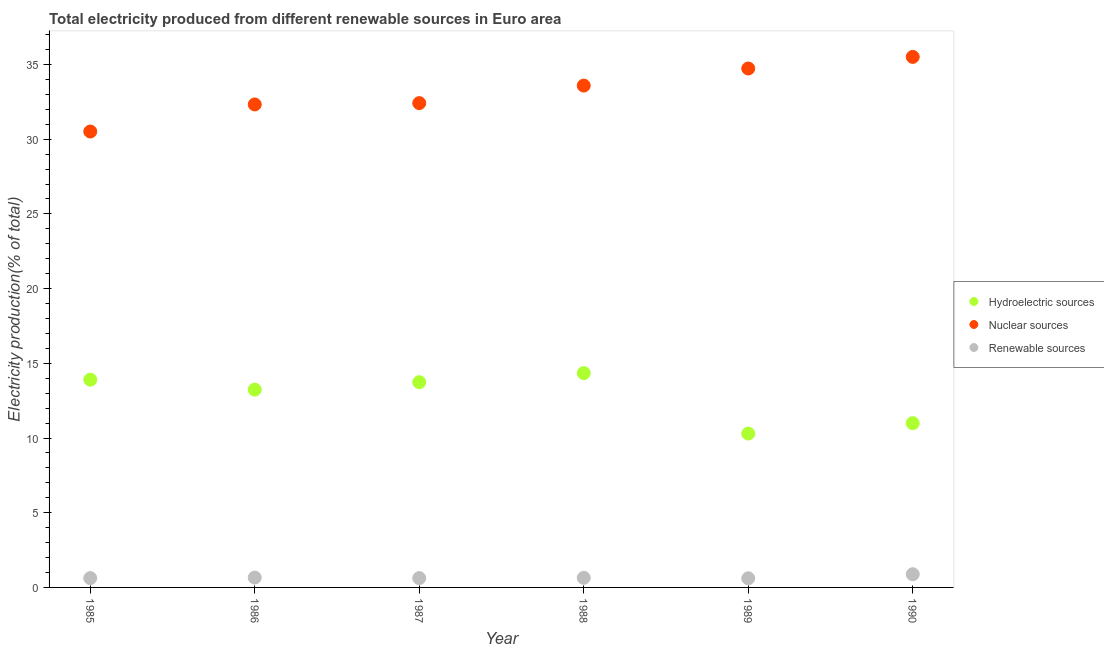What is the percentage of electricity produced by hydroelectric sources in 1988?
Make the answer very short. 14.34. Across all years, what is the maximum percentage of electricity produced by renewable sources?
Ensure brevity in your answer.  0.88. Across all years, what is the minimum percentage of electricity produced by nuclear sources?
Your response must be concise. 30.52. In which year was the percentage of electricity produced by renewable sources maximum?
Ensure brevity in your answer.  1990. What is the total percentage of electricity produced by nuclear sources in the graph?
Give a very brief answer. 199.1. What is the difference between the percentage of electricity produced by renewable sources in 1985 and that in 1990?
Offer a terse response. -0.26. What is the difference between the percentage of electricity produced by nuclear sources in 1987 and the percentage of electricity produced by renewable sources in 1988?
Provide a succinct answer. 31.77. What is the average percentage of electricity produced by renewable sources per year?
Provide a succinct answer. 0.67. In the year 1987, what is the difference between the percentage of electricity produced by nuclear sources and percentage of electricity produced by renewable sources?
Keep it short and to the point. 31.79. What is the ratio of the percentage of electricity produced by hydroelectric sources in 1986 to that in 1989?
Ensure brevity in your answer.  1.29. What is the difference between the highest and the second highest percentage of electricity produced by renewable sources?
Provide a short and direct response. 0.22. What is the difference between the highest and the lowest percentage of electricity produced by hydroelectric sources?
Your response must be concise. 4.04. Does the percentage of electricity produced by hydroelectric sources monotonically increase over the years?
Ensure brevity in your answer.  No. Is the percentage of electricity produced by hydroelectric sources strictly greater than the percentage of electricity produced by nuclear sources over the years?
Offer a terse response. No. How many dotlines are there?
Your answer should be compact. 3. Are the values on the major ticks of Y-axis written in scientific E-notation?
Provide a succinct answer. No. Does the graph contain any zero values?
Offer a terse response. No. Does the graph contain grids?
Make the answer very short. No. What is the title of the graph?
Ensure brevity in your answer.  Total electricity produced from different renewable sources in Euro area. What is the label or title of the Y-axis?
Ensure brevity in your answer.  Electricity production(% of total). What is the Electricity production(% of total) in Hydroelectric sources in 1985?
Offer a very short reply. 13.91. What is the Electricity production(% of total) of Nuclear sources in 1985?
Provide a short and direct response. 30.52. What is the Electricity production(% of total) in Renewable sources in 1985?
Provide a succinct answer. 0.62. What is the Electricity production(% of total) of Hydroelectric sources in 1986?
Give a very brief answer. 13.24. What is the Electricity production(% of total) of Nuclear sources in 1986?
Your response must be concise. 32.33. What is the Electricity production(% of total) in Renewable sources in 1986?
Your answer should be compact. 0.66. What is the Electricity production(% of total) in Hydroelectric sources in 1987?
Keep it short and to the point. 13.74. What is the Electricity production(% of total) of Nuclear sources in 1987?
Your response must be concise. 32.42. What is the Electricity production(% of total) of Renewable sources in 1987?
Give a very brief answer. 0.62. What is the Electricity production(% of total) in Hydroelectric sources in 1988?
Provide a succinct answer. 14.34. What is the Electricity production(% of total) of Nuclear sources in 1988?
Offer a very short reply. 33.59. What is the Electricity production(% of total) in Renewable sources in 1988?
Your answer should be compact. 0.64. What is the Electricity production(% of total) in Hydroelectric sources in 1989?
Your answer should be compact. 10.3. What is the Electricity production(% of total) in Nuclear sources in 1989?
Offer a very short reply. 34.74. What is the Electricity production(% of total) of Renewable sources in 1989?
Ensure brevity in your answer.  0.61. What is the Electricity production(% of total) of Hydroelectric sources in 1990?
Your response must be concise. 10.99. What is the Electricity production(% of total) of Nuclear sources in 1990?
Your answer should be very brief. 35.51. What is the Electricity production(% of total) of Renewable sources in 1990?
Make the answer very short. 0.88. Across all years, what is the maximum Electricity production(% of total) of Hydroelectric sources?
Keep it short and to the point. 14.34. Across all years, what is the maximum Electricity production(% of total) in Nuclear sources?
Your answer should be very brief. 35.51. Across all years, what is the maximum Electricity production(% of total) in Renewable sources?
Your response must be concise. 0.88. Across all years, what is the minimum Electricity production(% of total) in Hydroelectric sources?
Ensure brevity in your answer.  10.3. Across all years, what is the minimum Electricity production(% of total) in Nuclear sources?
Your response must be concise. 30.52. Across all years, what is the minimum Electricity production(% of total) in Renewable sources?
Offer a very short reply. 0.61. What is the total Electricity production(% of total) of Hydroelectric sources in the graph?
Offer a very short reply. 76.52. What is the total Electricity production(% of total) of Nuclear sources in the graph?
Make the answer very short. 199.1. What is the total Electricity production(% of total) in Renewable sources in the graph?
Offer a very short reply. 4.04. What is the difference between the Electricity production(% of total) of Hydroelectric sources in 1985 and that in 1986?
Your response must be concise. 0.66. What is the difference between the Electricity production(% of total) in Nuclear sources in 1985 and that in 1986?
Your answer should be compact. -1.81. What is the difference between the Electricity production(% of total) in Renewable sources in 1985 and that in 1986?
Give a very brief answer. -0.03. What is the difference between the Electricity production(% of total) of Hydroelectric sources in 1985 and that in 1987?
Offer a very short reply. 0.17. What is the difference between the Electricity production(% of total) in Nuclear sources in 1985 and that in 1987?
Offer a terse response. -1.9. What is the difference between the Electricity production(% of total) of Renewable sources in 1985 and that in 1987?
Make the answer very short. 0. What is the difference between the Electricity production(% of total) of Hydroelectric sources in 1985 and that in 1988?
Give a very brief answer. -0.44. What is the difference between the Electricity production(% of total) in Nuclear sources in 1985 and that in 1988?
Your answer should be compact. -3.07. What is the difference between the Electricity production(% of total) in Renewable sources in 1985 and that in 1988?
Provide a short and direct response. -0.02. What is the difference between the Electricity production(% of total) in Hydroelectric sources in 1985 and that in 1989?
Provide a short and direct response. 3.61. What is the difference between the Electricity production(% of total) of Nuclear sources in 1985 and that in 1989?
Your answer should be compact. -4.22. What is the difference between the Electricity production(% of total) in Renewable sources in 1985 and that in 1989?
Offer a very short reply. 0.01. What is the difference between the Electricity production(% of total) of Hydroelectric sources in 1985 and that in 1990?
Keep it short and to the point. 2.91. What is the difference between the Electricity production(% of total) of Nuclear sources in 1985 and that in 1990?
Offer a very short reply. -4.99. What is the difference between the Electricity production(% of total) in Renewable sources in 1985 and that in 1990?
Your response must be concise. -0.26. What is the difference between the Electricity production(% of total) in Hydroelectric sources in 1986 and that in 1987?
Make the answer very short. -0.5. What is the difference between the Electricity production(% of total) of Nuclear sources in 1986 and that in 1987?
Your response must be concise. -0.09. What is the difference between the Electricity production(% of total) in Renewable sources in 1986 and that in 1987?
Your response must be concise. 0.04. What is the difference between the Electricity production(% of total) in Hydroelectric sources in 1986 and that in 1988?
Provide a succinct answer. -1.1. What is the difference between the Electricity production(% of total) of Nuclear sources in 1986 and that in 1988?
Your answer should be compact. -1.26. What is the difference between the Electricity production(% of total) of Renewable sources in 1986 and that in 1988?
Provide a short and direct response. 0.02. What is the difference between the Electricity production(% of total) in Hydroelectric sources in 1986 and that in 1989?
Provide a succinct answer. 2.94. What is the difference between the Electricity production(% of total) in Nuclear sources in 1986 and that in 1989?
Provide a succinct answer. -2.41. What is the difference between the Electricity production(% of total) of Renewable sources in 1986 and that in 1989?
Offer a very short reply. 0.05. What is the difference between the Electricity production(% of total) of Hydroelectric sources in 1986 and that in 1990?
Your response must be concise. 2.25. What is the difference between the Electricity production(% of total) in Nuclear sources in 1986 and that in 1990?
Your response must be concise. -3.18. What is the difference between the Electricity production(% of total) of Renewable sources in 1986 and that in 1990?
Provide a succinct answer. -0.22. What is the difference between the Electricity production(% of total) in Hydroelectric sources in 1987 and that in 1988?
Provide a short and direct response. -0.61. What is the difference between the Electricity production(% of total) of Nuclear sources in 1987 and that in 1988?
Offer a very short reply. -1.17. What is the difference between the Electricity production(% of total) in Renewable sources in 1987 and that in 1988?
Make the answer very short. -0.02. What is the difference between the Electricity production(% of total) in Hydroelectric sources in 1987 and that in 1989?
Offer a terse response. 3.44. What is the difference between the Electricity production(% of total) in Nuclear sources in 1987 and that in 1989?
Your answer should be very brief. -2.32. What is the difference between the Electricity production(% of total) of Renewable sources in 1987 and that in 1989?
Offer a terse response. 0.01. What is the difference between the Electricity production(% of total) in Hydroelectric sources in 1987 and that in 1990?
Your response must be concise. 2.74. What is the difference between the Electricity production(% of total) in Nuclear sources in 1987 and that in 1990?
Ensure brevity in your answer.  -3.09. What is the difference between the Electricity production(% of total) of Renewable sources in 1987 and that in 1990?
Your answer should be compact. -0.26. What is the difference between the Electricity production(% of total) in Hydroelectric sources in 1988 and that in 1989?
Your answer should be very brief. 4.04. What is the difference between the Electricity production(% of total) of Nuclear sources in 1988 and that in 1989?
Keep it short and to the point. -1.14. What is the difference between the Electricity production(% of total) in Renewable sources in 1988 and that in 1989?
Offer a very short reply. 0.03. What is the difference between the Electricity production(% of total) of Hydroelectric sources in 1988 and that in 1990?
Your response must be concise. 3.35. What is the difference between the Electricity production(% of total) of Nuclear sources in 1988 and that in 1990?
Make the answer very short. -1.92. What is the difference between the Electricity production(% of total) of Renewable sources in 1988 and that in 1990?
Your answer should be very brief. -0.24. What is the difference between the Electricity production(% of total) of Hydroelectric sources in 1989 and that in 1990?
Give a very brief answer. -0.7. What is the difference between the Electricity production(% of total) in Nuclear sources in 1989 and that in 1990?
Provide a short and direct response. -0.78. What is the difference between the Electricity production(% of total) of Renewable sources in 1989 and that in 1990?
Ensure brevity in your answer.  -0.27. What is the difference between the Electricity production(% of total) of Hydroelectric sources in 1985 and the Electricity production(% of total) of Nuclear sources in 1986?
Make the answer very short. -18.42. What is the difference between the Electricity production(% of total) in Hydroelectric sources in 1985 and the Electricity production(% of total) in Renewable sources in 1986?
Provide a succinct answer. 13.25. What is the difference between the Electricity production(% of total) in Nuclear sources in 1985 and the Electricity production(% of total) in Renewable sources in 1986?
Your answer should be compact. 29.86. What is the difference between the Electricity production(% of total) of Hydroelectric sources in 1985 and the Electricity production(% of total) of Nuclear sources in 1987?
Make the answer very short. -18.51. What is the difference between the Electricity production(% of total) in Hydroelectric sources in 1985 and the Electricity production(% of total) in Renewable sources in 1987?
Your answer should be compact. 13.28. What is the difference between the Electricity production(% of total) of Nuclear sources in 1985 and the Electricity production(% of total) of Renewable sources in 1987?
Keep it short and to the point. 29.89. What is the difference between the Electricity production(% of total) in Hydroelectric sources in 1985 and the Electricity production(% of total) in Nuclear sources in 1988?
Provide a short and direct response. -19.69. What is the difference between the Electricity production(% of total) of Hydroelectric sources in 1985 and the Electricity production(% of total) of Renewable sources in 1988?
Provide a succinct answer. 13.26. What is the difference between the Electricity production(% of total) of Nuclear sources in 1985 and the Electricity production(% of total) of Renewable sources in 1988?
Your response must be concise. 29.87. What is the difference between the Electricity production(% of total) in Hydroelectric sources in 1985 and the Electricity production(% of total) in Nuclear sources in 1989?
Your answer should be compact. -20.83. What is the difference between the Electricity production(% of total) in Hydroelectric sources in 1985 and the Electricity production(% of total) in Renewable sources in 1989?
Keep it short and to the point. 13.29. What is the difference between the Electricity production(% of total) of Nuclear sources in 1985 and the Electricity production(% of total) of Renewable sources in 1989?
Ensure brevity in your answer.  29.91. What is the difference between the Electricity production(% of total) in Hydroelectric sources in 1985 and the Electricity production(% of total) in Nuclear sources in 1990?
Your response must be concise. -21.61. What is the difference between the Electricity production(% of total) of Hydroelectric sources in 1985 and the Electricity production(% of total) of Renewable sources in 1990?
Provide a succinct answer. 13.02. What is the difference between the Electricity production(% of total) in Nuclear sources in 1985 and the Electricity production(% of total) in Renewable sources in 1990?
Ensure brevity in your answer.  29.63. What is the difference between the Electricity production(% of total) in Hydroelectric sources in 1986 and the Electricity production(% of total) in Nuclear sources in 1987?
Ensure brevity in your answer.  -19.18. What is the difference between the Electricity production(% of total) in Hydroelectric sources in 1986 and the Electricity production(% of total) in Renewable sources in 1987?
Ensure brevity in your answer.  12.62. What is the difference between the Electricity production(% of total) of Nuclear sources in 1986 and the Electricity production(% of total) of Renewable sources in 1987?
Offer a terse response. 31.71. What is the difference between the Electricity production(% of total) in Hydroelectric sources in 1986 and the Electricity production(% of total) in Nuclear sources in 1988?
Ensure brevity in your answer.  -20.35. What is the difference between the Electricity production(% of total) of Hydroelectric sources in 1986 and the Electricity production(% of total) of Renewable sources in 1988?
Make the answer very short. 12.6. What is the difference between the Electricity production(% of total) of Nuclear sources in 1986 and the Electricity production(% of total) of Renewable sources in 1988?
Your answer should be compact. 31.69. What is the difference between the Electricity production(% of total) in Hydroelectric sources in 1986 and the Electricity production(% of total) in Nuclear sources in 1989?
Your response must be concise. -21.49. What is the difference between the Electricity production(% of total) in Hydroelectric sources in 1986 and the Electricity production(% of total) in Renewable sources in 1989?
Provide a succinct answer. 12.63. What is the difference between the Electricity production(% of total) in Nuclear sources in 1986 and the Electricity production(% of total) in Renewable sources in 1989?
Offer a terse response. 31.72. What is the difference between the Electricity production(% of total) of Hydroelectric sources in 1986 and the Electricity production(% of total) of Nuclear sources in 1990?
Offer a terse response. -22.27. What is the difference between the Electricity production(% of total) of Hydroelectric sources in 1986 and the Electricity production(% of total) of Renewable sources in 1990?
Give a very brief answer. 12.36. What is the difference between the Electricity production(% of total) of Nuclear sources in 1986 and the Electricity production(% of total) of Renewable sources in 1990?
Offer a terse response. 31.45. What is the difference between the Electricity production(% of total) in Hydroelectric sources in 1987 and the Electricity production(% of total) in Nuclear sources in 1988?
Your answer should be very brief. -19.85. What is the difference between the Electricity production(% of total) in Hydroelectric sources in 1987 and the Electricity production(% of total) in Renewable sources in 1988?
Your response must be concise. 13.09. What is the difference between the Electricity production(% of total) of Nuclear sources in 1987 and the Electricity production(% of total) of Renewable sources in 1988?
Provide a succinct answer. 31.77. What is the difference between the Electricity production(% of total) of Hydroelectric sources in 1987 and the Electricity production(% of total) of Nuclear sources in 1989?
Make the answer very short. -21. What is the difference between the Electricity production(% of total) in Hydroelectric sources in 1987 and the Electricity production(% of total) in Renewable sources in 1989?
Provide a succinct answer. 13.13. What is the difference between the Electricity production(% of total) of Nuclear sources in 1987 and the Electricity production(% of total) of Renewable sources in 1989?
Your response must be concise. 31.81. What is the difference between the Electricity production(% of total) of Hydroelectric sources in 1987 and the Electricity production(% of total) of Nuclear sources in 1990?
Make the answer very short. -21.77. What is the difference between the Electricity production(% of total) in Hydroelectric sources in 1987 and the Electricity production(% of total) in Renewable sources in 1990?
Your answer should be very brief. 12.85. What is the difference between the Electricity production(% of total) in Nuclear sources in 1987 and the Electricity production(% of total) in Renewable sources in 1990?
Provide a short and direct response. 31.53. What is the difference between the Electricity production(% of total) in Hydroelectric sources in 1988 and the Electricity production(% of total) in Nuclear sources in 1989?
Ensure brevity in your answer.  -20.39. What is the difference between the Electricity production(% of total) in Hydroelectric sources in 1988 and the Electricity production(% of total) in Renewable sources in 1989?
Give a very brief answer. 13.73. What is the difference between the Electricity production(% of total) in Nuclear sources in 1988 and the Electricity production(% of total) in Renewable sources in 1989?
Your answer should be very brief. 32.98. What is the difference between the Electricity production(% of total) of Hydroelectric sources in 1988 and the Electricity production(% of total) of Nuclear sources in 1990?
Keep it short and to the point. -21.17. What is the difference between the Electricity production(% of total) of Hydroelectric sources in 1988 and the Electricity production(% of total) of Renewable sources in 1990?
Your response must be concise. 13.46. What is the difference between the Electricity production(% of total) of Nuclear sources in 1988 and the Electricity production(% of total) of Renewable sources in 1990?
Give a very brief answer. 32.71. What is the difference between the Electricity production(% of total) in Hydroelectric sources in 1989 and the Electricity production(% of total) in Nuclear sources in 1990?
Offer a very short reply. -25.21. What is the difference between the Electricity production(% of total) of Hydroelectric sources in 1989 and the Electricity production(% of total) of Renewable sources in 1990?
Provide a succinct answer. 9.42. What is the difference between the Electricity production(% of total) in Nuclear sources in 1989 and the Electricity production(% of total) in Renewable sources in 1990?
Keep it short and to the point. 33.85. What is the average Electricity production(% of total) in Hydroelectric sources per year?
Offer a very short reply. 12.75. What is the average Electricity production(% of total) of Nuclear sources per year?
Offer a very short reply. 33.18. What is the average Electricity production(% of total) in Renewable sources per year?
Give a very brief answer. 0.67. In the year 1985, what is the difference between the Electricity production(% of total) of Hydroelectric sources and Electricity production(% of total) of Nuclear sources?
Provide a succinct answer. -16.61. In the year 1985, what is the difference between the Electricity production(% of total) in Hydroelectric sources and Electricity production(% of total) in Renewable sources?
Provide a short and direct response. 13.28. In the year 1985, what is the difference between the Electricity production(% of total) in Nuclear sources and Electricity production(% of total) in Renewable sources?
Your answer should be very brief. 29.89. In the year 1986, what is the difference between the Electricity production(% of total) in Hydroelectric sources and Electricity production(% of total) in Nuclear sources?
Provide a succinct answer. -19.09. In the year 1986, what is the difference between the Electricity production(% of total) in Hydroelectric sources and Electricity production(% of total) in Renewable sources?
Offer a very short reply. 12.58. In the year 1986, what is the difference between the Electricity production(% of total) of Nuclear sources and Electricity production(% of total) of Renewable sources?
Your answer should be very brief. 31.67. In the year 1987, what is the difference between the Electricity production(% of total) of Hydroelectric sources and Electricity production(% of total) of Nuclear sources?
Offer a very short reply. -18.68. In the year 1987, what is the difference between the Electricity production(% of total) of Hydroelectric sources and Electricity production(% of total) of Renewable sources?
Give a very brief answer. 13.11. In the year 1987, what is the difference between the Electricity production(% of total) in Nuclear sources and Electricity production(% of total) in Renewable sources?
Make the answer very short. 31.79. In the year 1988, what is the difference between the Electricity production(% of total) of Hydroelectric sources and Electricity production(% of total) of Nuclear sources?
Offer a terse response. -19.25. In the year 1988, what is the difference between the Electricity production(% of total) in Hydroelectric sources and Electricity production(% of total) in Renewable sources?
Your answer should be compact. 13.7. In the year 1988, what is the difference between the Electricity production(% of total) of Nuclear sources and Electricity production(% of total) of Renewable sources?
Your response must be concise. 32.95. In the year 1989, what is the difference between the Electricity production(% of total) in Hydroelectric sources and Electricity production(% of total) in Nuclear sources?
Provide a short and direct response. -24.44. In the year 1989, what is the difference between the Electricity production(% of total) in Hydroelectric sources and Electricity production(% of total) in Renewable sources?
Your response must be concise. 9.69. In the year 1989, what is the difference between the Electricity production(% of total) in Nuclear sources and Electricity production(% of total) in Renewable sources?
Your answer should be very brief. 34.12. In the year 1990, what is the difference between the Electricity production(% of total) of Hydroelectric sources and Electricity production(% of total) of Nuclear sources?
Ensure brevity in your answer.  -24.52. In the year 1990, what is the difference between the Electricity production(% of total) in Hydroelectric sources and Electricity production(% of total) in Renewable sources?
Offer a very short reply. 10.11. In the year 1990, what is the difference between the Electricity production(% of total) in Nuclear sources and Electricity production(% of total) in Renewable sources?
Ensure brevity in your answer.  34.63. What is the ratio of the Electricity production(% of total) in Hydroelectric sources in 1985 to that in 1986?
Ensure brevity in your answer.  1.05. What is the ratio of the Electricity production(% of total) of Nuclear sources in 1985 to that in 1986?
Keep it short and to the point. 0.94. What is the ratio of the Electricity production(% of total) in Renewable sources in 1985 to that in 1986?
Keep it short and to the point. 0.95. What is the ratio of the Electricity production(% of total) in Hydroelectric sources in 1985 to that in 1987?
Keep it short and to the point. 1.01. What is the ratio of the Electricity production(% of total) of Nuclear sources in 1985 to that in 1987?
Make the answer very short. 0.94. What is the ratio of the Electricity production(% of total) in Hydroelectric sources in 1985 to that in 1988?
Your response must be concise. 0.97. What is the ratio of the Electricity production(% of total) of Nuclear sources in 1985 to that in 1988?
Provide a short and direct response. 0.91. What is the ratio of the Electricity production(% of total) in Renewable sources in 1985 to that in 1988?
Your answer should be compact. 0.97. What is the ratio of the Electricity production(% of total) of Hydroelectric sources in 1985 to that in 1989?
Your response must be concise. 1.35. What is the ratio of the Electricity production(% of total) in Nuclear sources in 1985 to that in 1989?
Keep it short and to the point. 0.88. What is the ratio of the Electricity production(% of total) of Renewable sources in 1985 to that in 1989?
Your answer should be compact. 1.02. What is the ratio of the Electricity production(% of total) in Hydroelectric sources in 1985 to that in 1990?
Provide a succinct answer. 1.26. What is the ratio of the Electricity production(% of total) of Nuclear sources in 1985 to that in 1990?
Provide a succinct answer. 0.86. What is the ratio of the Electricity production(% of total) of Renewable sources in 1985 to that in 1990?
Keep it short and to the point. 0.71. What is the ratio of the Electricity production(% of total) of Hydroelectric sources in 1986 to that in 1987?
Give a very brief answer. 0.96. What is the ratio of the Electricity production(% of total) of Nuclear sources in 1986 to that in 1987?
Provide a short and direct response. 1. What is the ratio of the Electricity production(% of total) of Renewable sources in 1986 to that in 1987?
Ensure brevity in your answer.  1.06. What is the ratio of the Electricity production(% of total) in Hydroelectric sources in 1986 to that in 1988?
Your answer should be compact. 0.92. What is the ratio of the Electricity production(% of total) in Nuclear sources in 1986 to that in 1988?
Offer a very short reply. 0.96. What is the ratio of the Electricity production(% of total) of Renewable sources in 1986 to that in 1988?
Ensure brevity in your answer.  1.03. What is the ratio of the Electricity production(% of total) of Hydroelectric sources in 1986 to that in 1989?
Provide a short and direct response. 1.29. What is the ratio of the Electricity production(% of total) in Nuclear sources in 1986 to that in 1989?
Your answer should be very brief. 0.93. What is the ratio of the Electricity production(% of total) of Renewable sources in 1986 to that in 1989?
Your answer should be compact. 1.08. What is the ratio of the Electricity production(% of total) in Hydroelectric sources in 1986 to that in 1990?
Provide a succinct answer. 1.2. What is the ratio of the Electricity production(% of total) of Nuclear sources in 1986 to that in 1990?
Offer a terse response. 0.91. What is the ratio of the Electricity production(% of total) in Renewable sources in 1986 to that in 1990?
Your answer should be compact. 0.75. What is the ratio of the Electricity production(% of total) in Hydroelectric sources in 1987 to that in 1988?
Make the answer very short. 0.96. What is the ratio of the Electricity production(% of total) of Nuclear sources in 1987 to that in 1988?
Your response must be concise. 0.96. What is the ratio of the Electricity production(% of total) of Renewable sources in 1987 to that in 1988?
Ensure brevity in your answer.  0.97. What is the ratio of the Electricity production(% of total) of Hydroelectric sources in 1987 to that in 1989?
Offer a very short reply. 1.33. What is the ratio of the Electricity production(% of total) in Nuclear sources in 1987 to that in 1989?
Keep it short and to the point. 0.93. What is the ratio of the Electricity production(% of total) in Renewable sources in 1987 to that in 1989?
Ensure brevity in your answer.  1.02. What is the ratio of the Electricity production(% of total) in Hydroelectric sources in 1987 to that in 1990?
Offer a very short reply. 1.25. What is the ratio of the Electricity production(% of total) of Nuclear sources in 1987 to that in 1990?
Provide a succinct answer. 0.91. What is the ratio of the Electricity production(% of total) of Renewable sources in 1987 to that in 1990?
Make the answer very short. 0.7. What is the ratio of the Electricity production(% of total) of Hydroelectric sources in 1988 to that in 1989?
Provide a succinct answer. 1.39. What is the ratio of the Electricity production(% of total) of Nuclear sources in 1988 to that in 1989?
Give a very brief answer. 0.97. What is the ratio of the Electricity production(% of total) of Renewable sources in 1988 to that in 1989?
Your answer should be very brief. 1.05. What is the ratio of the Electricity production(% of total) of Hydroelectric sources in 1988 to that in 1990?
Your answer should be compact. 1.3. What is the ratio of the Electricity production(% of total) of Nuclear sources in 1988 to that in 1990?
Ensure brevity in your answer.  0.95. What is the ratio of the Electricity production(% of total) in Renewable sources in 1988 to that in 1990?
Your response must be concise. 0.73. What is the ratio of the Electricity production(% of total) in Hydroelectric sources in 1989 to that in 1990?
Your response must be concise. 0.94. What is the ratio of the Electricity production(% of total) of Nuclear sources in 1989 to that in 1990?
Your answer should be very brief. 0.98. What is the ratio of the Electricity production(% of total) in Renewable sources in 1989 to that in 1990?
Your answer should be very brief. 0.69. What is the difference between the highest and the second highest Electricity production(% of total) of Hydroelectric sources?
Make the answer very short. 0.44. What is the difference between the highest and the second highest Electricity production(% of total) in Nuclear sources?
Your response must be concise. 0.78. What is the difference between the highest and the second highest Electricity production(% of total) in Renewable sources?
Keep it short and to the point. 0.22. What is the difference between the highest and the lowest Electricity production(% of total) in Hydroelectric sources?
Keep it short and to the point. 4.04. What is the difference between the highest and the lowest Electricity production(% of total) in Nuclear sources?
Your response must be concise. 4.99. What is the difference between the highest and the lowest Electricity production(% of total) of Renewable sources?
Ensure brevity in your answer.  0.27. 